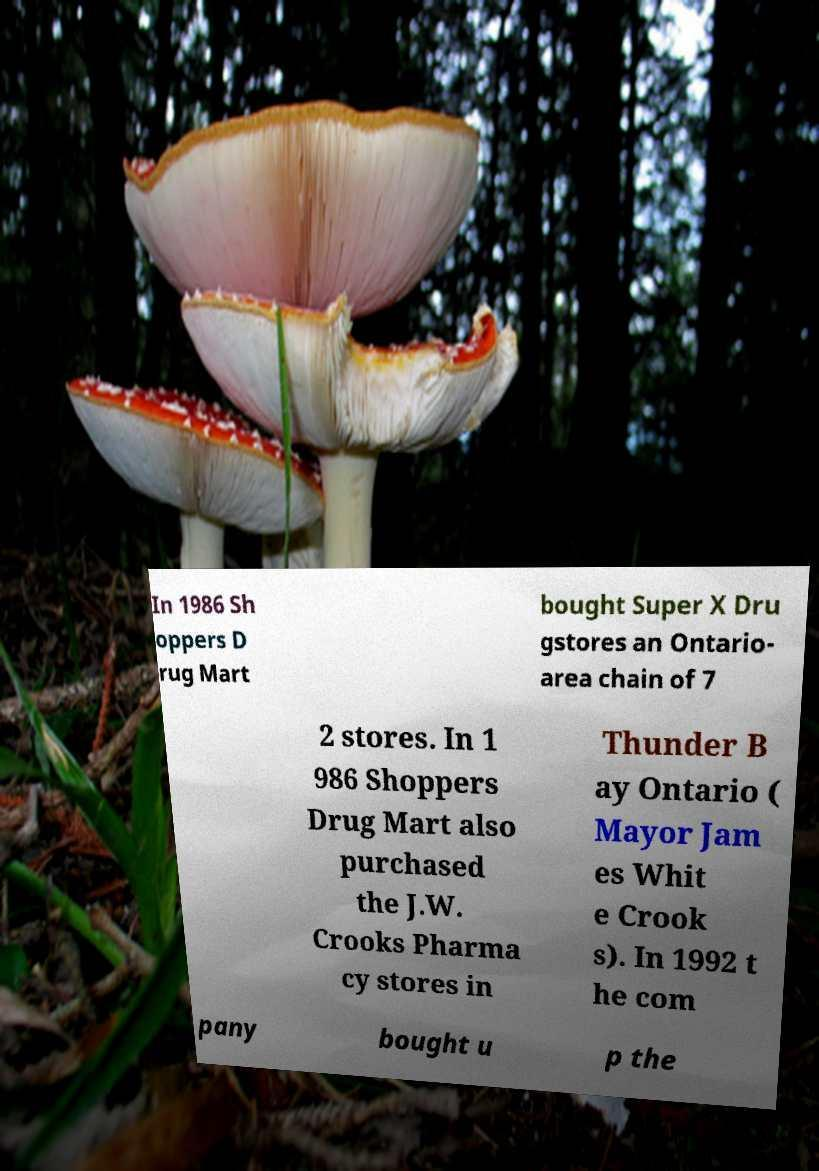I need the written content from this picture converted into text. Can you do that? In 1986 Sh oppers D rug Mart bought Super X Dru gstores an Ontario- area chain of 7 2 stores. In 1 986 Shoppers Drug Mart also purchased the J.W. Crooks Pharma cy stores in Thunder B ay Ontario ( Mayor Jam es Whit e Crook s). In 1992 t he com pany bought u p the 